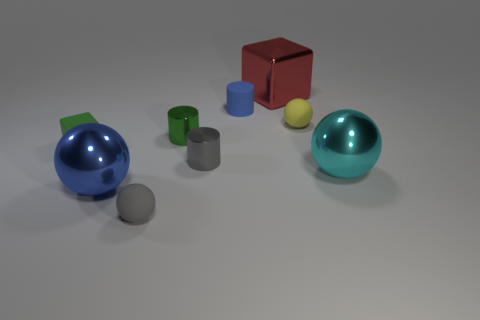Subtract all yellow matte spheres. How many spheres are left? 3 Subtract all cyan balls. How many balls are left? 3 Subtract all brown spheres. Subtract all green cylinders. How many spheres are left? 4 Subtract all cylinders. How many objects are left? 6 Subtract all matte cylinders. Subtract all large blue balls. How many objects are left? 7 Add 6 green cylinders. How many green cylinders are left? 7 Add 5 blue things. How many blue things exist? 7 Subtract 1 yellow spheres. How many objects are left? 8 